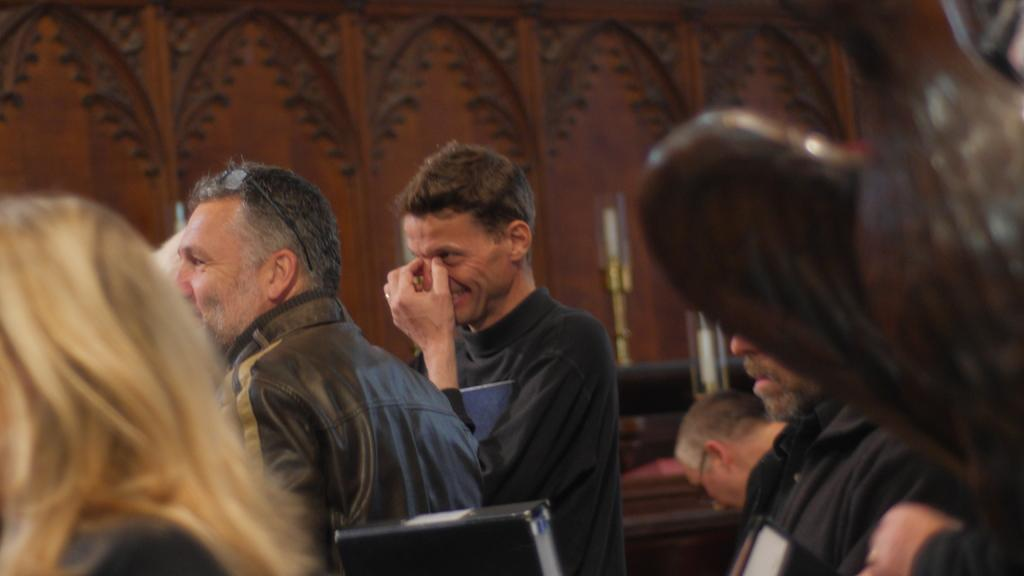How many people are in the image? There are persons in the image. Can you describe one of the persons in the image? There is a person with glasses on his head. What objects can be seen in the image besides the persons? There are two candles in the image. What type of force is being applied to the toys in the image? There are no toys present in the image, so it is not possible to determine if any force is being applied to them. 